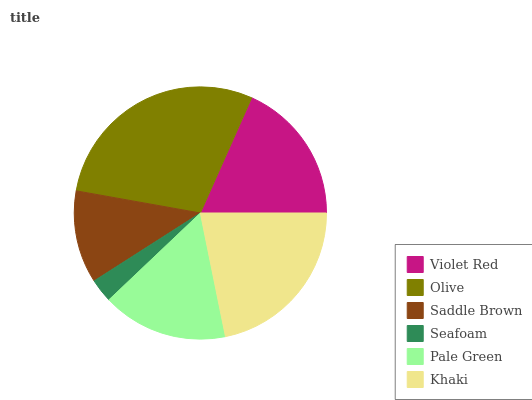Is Seafoam the minimum?
Answer yes or no. Yes. Is Olive the maximum?
Answer yes or no. Yes. Is Saddle Brown the minimum?
Answer yes or no. No. Is Saddle Brown the maximum?
Answer yes or no. No. Is Olive greater than Saddle Brown?
Answer yes or no. Yes. Is Saddle Brown less than Olive?
Answer yes or no. Yes. Is Saddle Brown greater than Olive?
Answer yes or no. No. Is Olive less than Saddle Brown?
Answer yes or no. No. Is Violet Red the high median?
Answer yes or no. Yes. Is Pale Green the low median?
Answer yes or no. Yes. Is Olive the high median?
Answer yes or no. No. Is Khaki the low median?
Answer yes or no. No. 